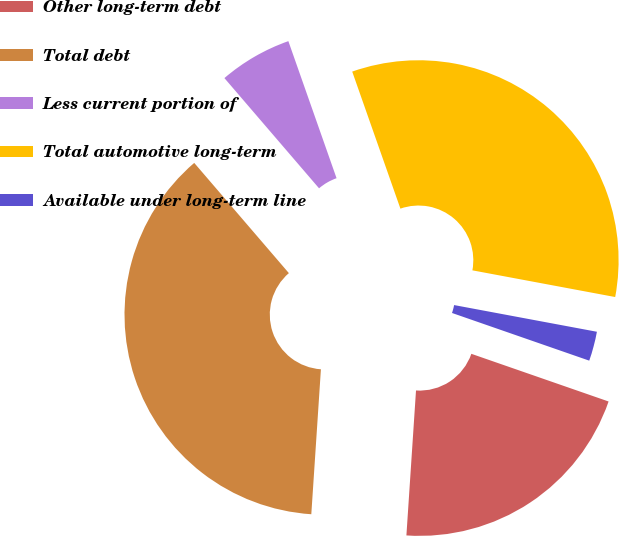Convert chart to OTSL. <chart><loc_0><loc_0><loc_500><loc_500><pie_chart><fcel>Other long-term debt<fcel>Total debt<fcel>Less current portion of<fcel>Total automotive long-term<fcel>Available under long-term line<nl><fcel>20.73%<fcel>37.65%<fcel>5.91%<fcel>33.32%<fcel>2.38%<nl></chart> 